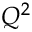Convert formula to latex. <formula><loc_0><loc_0><loc_500><loc_500>Q ^ { 2 }</formula> 